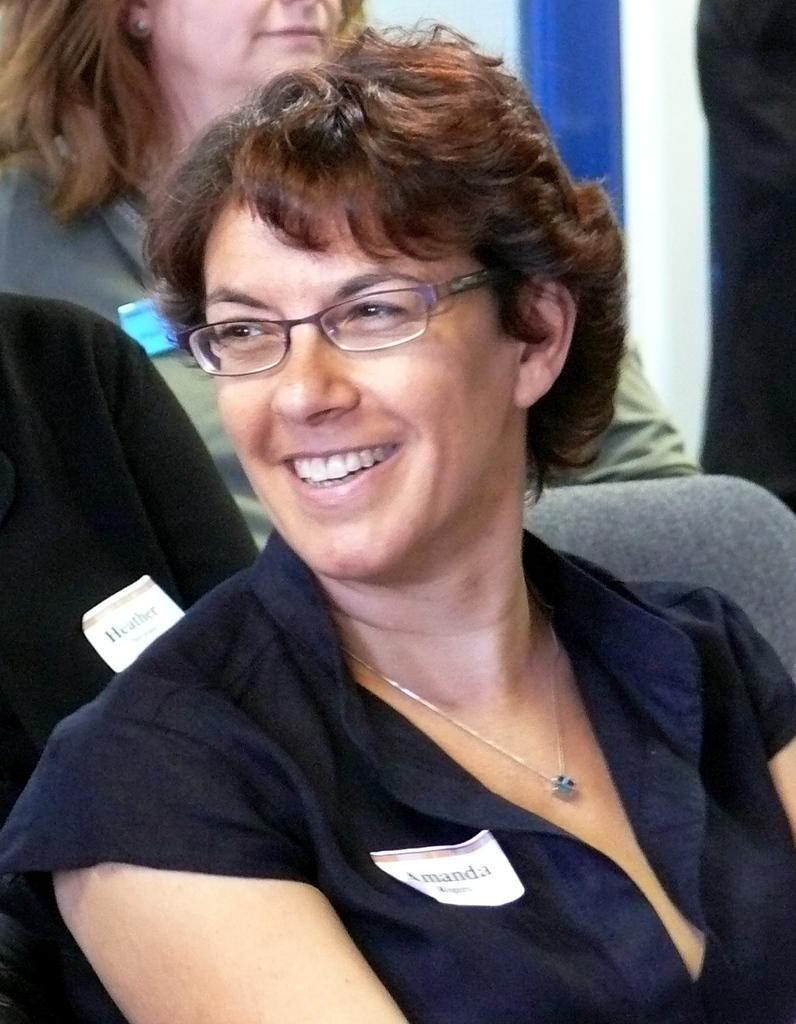Who is the main subject in the image? There is a woman in the image. What is the woman wearing? The woman is wearing spectacles. What is the woman doing in the image? The woman is sitting on a chair and smiling. Can you describe the background of the image? There are people in the background of the image. What type of park can be seen in the background of the image? There is no park visible in the background of the image. How many fingers is the woman holding up in the image? The image does not show the woman holding up any fingers, so it cannot be determined from the image. 